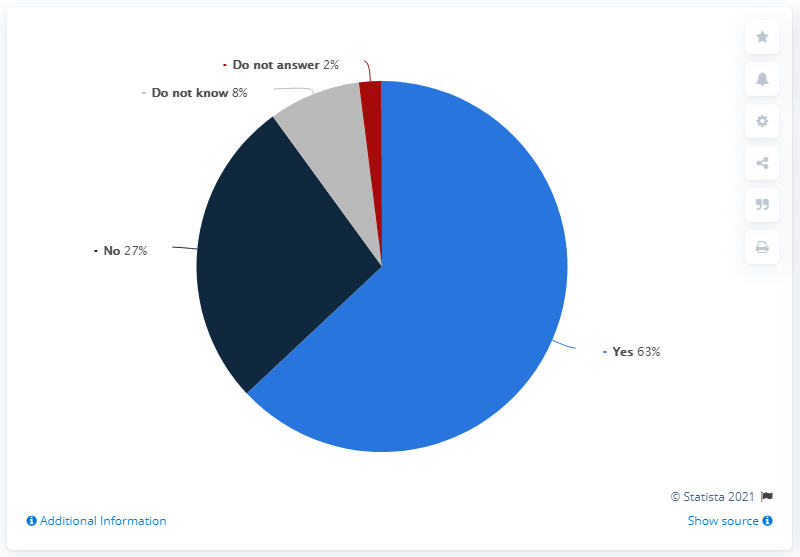Point out several critical features in this image. Out of 10 people surveyed, no one was able to provide a response or answer regarding same-sex marriage. The majority of people gave a response of "yes" on the topic of same-sex marriage. 